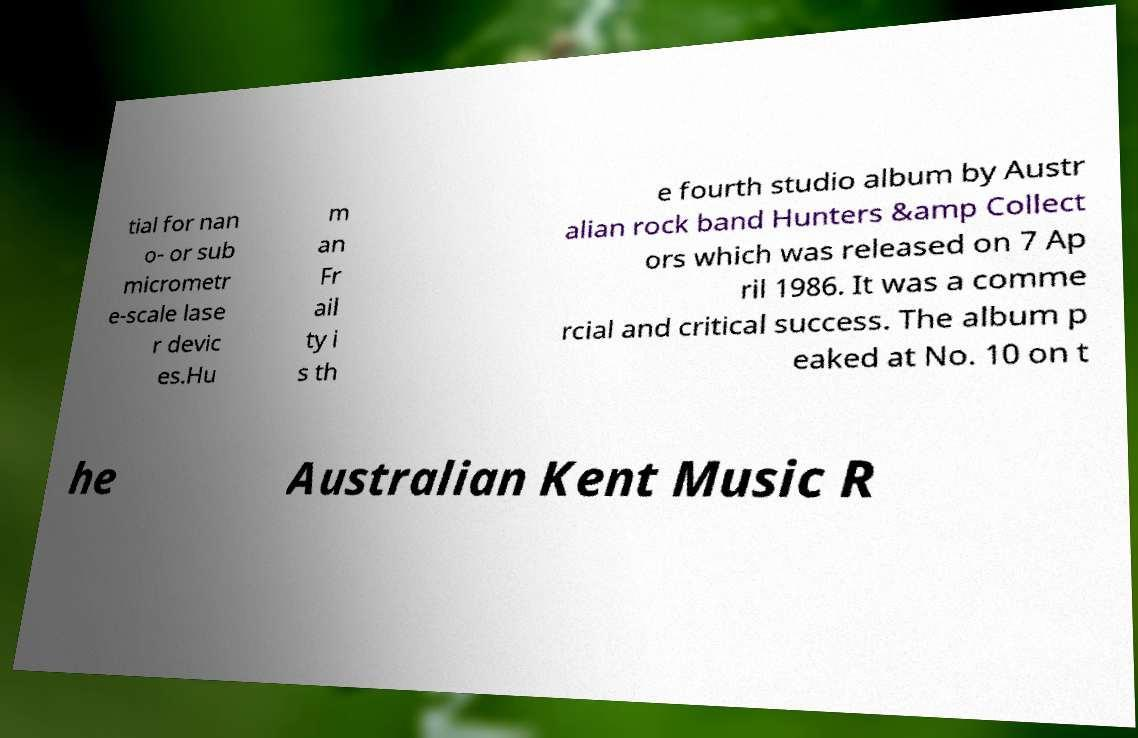I need the written content from this picture converted into text. Can you do that? tial for nan o- or sub micrometr e-scale lase r devic es.Hu m an Fr ail ty i s th e fourth studio album by Austr alian rock band Hunters &amp Collect ors which was released on 7 Ap ril 1986. It was a comme rcial and critical success. The album p eaked at No. 10 on t he Australian Kent Music R 